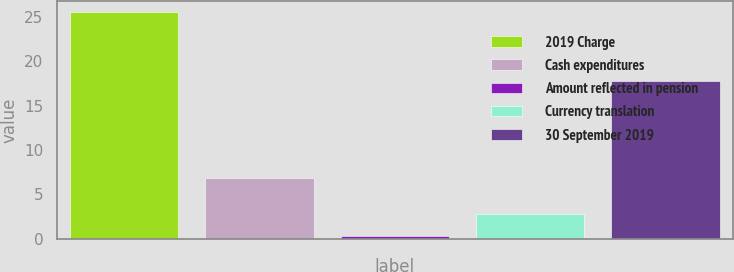Convert chart to OTSL. <chart><loc_0><loc_0><loc_500><loc_500><bar_chart><fcel>2019 Charge<fcel>Cash expenditures<fcel>Amount reflected in pension<fcel>Currency translation<fcel>30 September 2019<nl><fcel>25.5<fcel>6.9<fcel>0.3<fcel>2.82<fcel>17.8<nl></chart> 